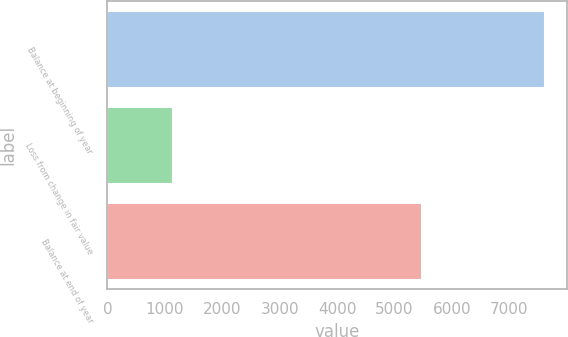Convert chart to OTSL. <chart><loc_0><loc_0><loc_500><loc_500><bar_chart><fcel>Balance at beginning of year<fcel>Loss from change in fair value<fcel>Balance at end of year<nl><fcel>7618<fcel>1144<fcel>5484<nl></chart> 